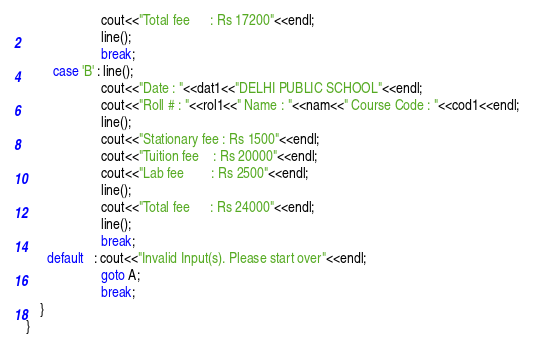<code> <loc_0><loc_0><loc_500><loc_500><_C++_>					  cout<<"Total fee      : Rs 17200"<<endl;
					  line();
					  break;
		case 'B' : line();
					  cout<<"Date : "<<dat1<<"DELHI PUBLIC SCHOOL"<<endl;
					  cout<<"Roll # : "<<rol1<<" Name : "<<nam<<" Course Code : "<<cod1<<endl;
					  line();
					  cout<<"Stationary fee : Rs 1500"<<endl;
					  cout<<"Tuition fee    : Rs 20000"<<endl;
					  cout<<"Lab fee        : Rs 2500"<<endl;
					  line();
					  cout<<"Total fee      : Rs 24000"<<endl;
					  line();
					  break;
	  default   : cout<<"Invalid Input(s). Please start over"<<endl;
					  goto A;
					  break;
	}
}</code> 